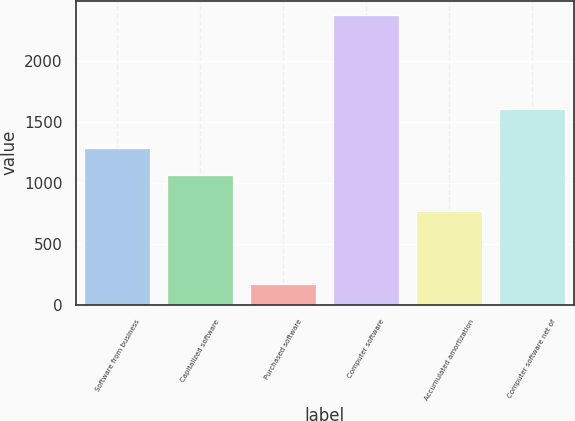Convert chart. <chart><loc_0><loc_0><loc_500><loc_500><bar_chart><fcel>Software from business<fcel>Capitalized software<fcel>Purchased software<fcel>Computer software<fcel>Accumulated amortization<fcel>Computer software net of<nl><fcel>1286.4<fcel>1066<fcel>172<fcel>2376<fcel>768<fcel>1608<nl></chart> 